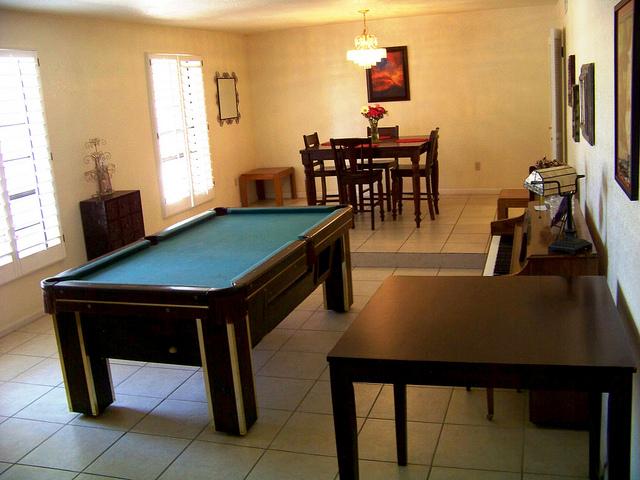Is this a restaurant?
Concise answer only. No. How many tables are in the room?
Give a very brief answer. 5. Are there flowers on any of the tables?
Answer briefly. Yes. What is green?
Keep it brief. Pool table. Are there pool balls on the table?
Be succinct. No. Is this a new invention?
Short answer required. No. How many lights are hanging from the ceiling?
Write a very short answer. 1. How many people can sit at the same table?
Concise answer only. 4. What kind of room is this?
Write a very short answer. Game room. How many lights are on?
Quick response, please. 1. 